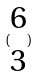Convert formula to latex. <formula><loc_0><loc_0><loc_500><loc_500>( \begin{matrix} 6 \\ 3 \end{matrix} )</formula> 